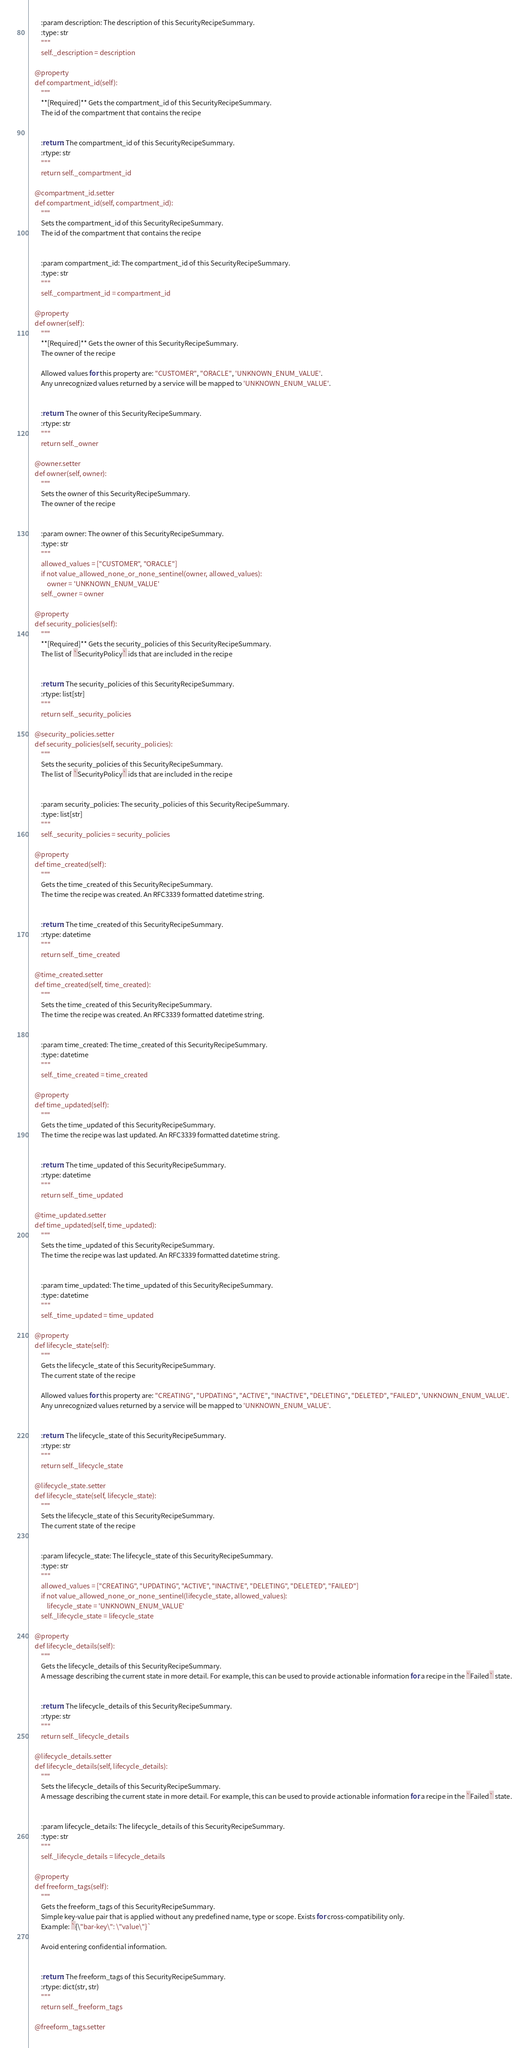<code> <loc_0><loc_0><loc_500><loc_500><_Python_>        :param description: The description of this SecurityRecipeSummary.
        :type: str
        """
        self._description = description

    @property
    def compartment_id(self):
        """
        **[Required]** Gets the compartment_id of this SecurityRecipeSummary.
        The id of the compartment that contains the recipe


        :return: The compartment_id of this SecurityRecipeSummary.
        :rtype: str
        """
        return self._compartment_id

    @compartment_id.setter
    def compartment_id(self, compartment_id):
        """
        Sets the compartment_id of this SecurityRecipeSummary.
        The id of the compartment that contains the recipe


        :param compartment_id: The compartment_id of this SecurityRecipeSummary.
        :type: str
        """
        self._compartment_id = compartment_id

    @property
    def owner(self):
        """
        **[Required]** Gets the owner of this SecurityRecipeSummary.
        The owner of the recipe

        Allowed values for this property are: "CUSTOMER", "ORACLE", 'UNKNOWN_ENUM_VALUE'.
        Any unrecognized values returned by a service will be mapped to 'UNKNOWN_ENUM_VALUE'.


        :return: The owner of this SecurityRecipeSummary.
        :rtype: str
        """
        return self._owner

    @owner.setter
    def owner(self, owner):
        """
        Sets the owner of this SecurityRecipeSummary.
        The owner of the recipe


        :param owner: The owner of this SecurityRecipeSummary.
        :type: str
        """
        allowed_values = ["CUSTOMER", "ORACLE"]
        if not value_allowed_none_or_none_sentinel(owner, allowed_values):
            owner = 'UNKNOWN_ENUM_VALUE'
        self._owner = owner

    @property
    def security_policies(self):
        """
        **[Required]** Gets the security_policies of this SecurityRecipeSummary.
        The list of `SecurityPolicy` ids that are included in the recipe


        :return: The security_policies of this SecurityRecipeSummary.
        :rtype: list[str]
        """
        return self._security_policies

    @security_policies.setter
    def security_policies(self, security_policies):
        """
        Sets the security_policies of this SecurityRecipeSummary.
        The list of `SecurityPolicy` ids that are included in the recipe


        :param security_policies: The security_policies of this SecurityRecipeSummary.
        :type: list[str]
        """
        self._security_policies = security_policies

    @property
    def time_created(self):
        """
        Gets the time_created of this SecurityRecipeSummary.
        The time the recipe was created. An RFC3339 formatted datetime string.


        :return: The time_created of this SecurityRecipeSummary.
        :rtype: datetime
        """
        return self._time_created

    @time_created.setter
    def time_created(self, time_created):
        """
        Sets the time_created of this SecurityRecipeSummary.
        The time the recipe was created. An RFC3339 formatted datetime string.


        :param time_created: The time_created of this SecurityRecipeSummary.
        :type: datetime
        """
        self._time_created = time_created

    @property
    def time_updated(self):
        """
        Gets the time_updated of this SecurityRecipeSummary.
        The time the recipe was last updated. An RFC3339 formatted datetime string.


        :return: The time_updated of this SecurityRecipeSummary.
        :rtype: datetime
        """
        return self._time_updated

    @time_updated.setter
    def time_updated(self, time_updated):
        """
        Sets the time_updated of this SecurityRecipeSummary.
        The time the recipe was last updated. An RFC3339 formatted datetime string.


        :param time_updated: The time_updated of this SecurityRecipeSummary.
        :type: datetime
        """
        self._time_updated = time_updated

    @property
    def lifecycle_state(self):
        """
        Gets the lifecycle_state of this SecurityRecipeSummary.
        The current state of the recipe

        Allowed values for this property are: "CREATING", "UPDATING", "ACTIVE", "INACTIVE", "DELETING", "DELETED", "FAILED", 'UNKNOWN_ENUM_VALUE'.
        Any unrecognized values returned by a service will be mapped to 'UNKNOWN_ENUM_VALUE'.


        :return: The lifecycle_state of this SecurityRecipeSummary.
        :rtype: str
        """
        return self._lifecycle_state

    @lifecycle_state.setter
    def lifecycle_state(self, lifecycle_state):
        """
        Sets the lifecycle_state of this SecurityRecipeSummary.
        The current state of the recipe


        :param lifecycle_state: The lifecycle_state of this SecurityRecipeSummary.
        :type: str
        """
        allowed_values = ["CREATING", "UPDATING", "ACTIVE", "INACTIVE", "DELETING", "DELETED", "FAILED"]
        if not value_allowed_none_or_none_sentinel(lifecycle_state, allowed_values):
            lifecycle_state = 'UNKNOWN_ENUM_VALUE'
        self._lifecycle_state = lifecycle_state

    @property
    def lifecycle_details(self):
        """
        Gets the lifecycle_details of this SecurityRecipeSummary.
        A message describing the current state in more detail. For example, this can be used to provide actionable information for a recipe in the `Failed` state.


        :return: The lifecycle_details of this SecurityRecipeSummary.
        :rtype: str
        """
        return self._lifecycle_details

    @lifecycle_details.setter
    def lifecycle_details(self, lifecycle_details):
        """
        Sets the lifecycle_details of this SecurityRecipeSummary.
        A message describing the current state in more detail. For example, this can be used to provide actionable information for a recipe in the `Failed` state.


        :param lifecycle_details: The lifecycle_details of this SecurityRecipeSummary.
        :type: str
        """
        self._lifecycle_details = lifecycle_details

    @property
    def freeform_tags(self):
        """
        Gets the freeform_tags of this SecurityRecipeSummary.
        Simple key-value pair that is applied without any predefined name, type or scope. Exists for cross-compatibility only.
        Example: `{\"bar-key\": \"value\"}`

        Avoid entering confidential information.


        :return: The freeform_tags of this SecurityRecipeSummary.
        :rtype: dict(str, str)
        """
        return self._freeform_tags

    @freeform_tags.setter</code> 